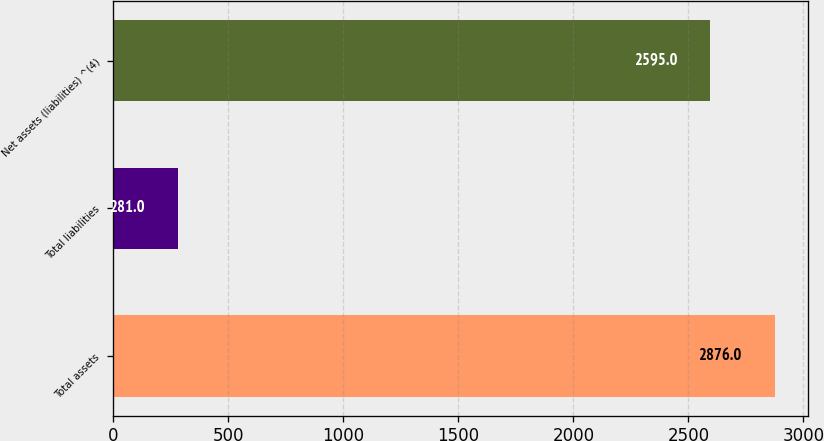Convert chart. <chart><loc_0><loc_0><loc_500><loc_500><bar_chart><fcel>Total assets<fcel>Total liabilities<fcel>Net assets (liabilities) ^(4)<nl><fcel>2876<fcel>281<fcel>2595<nl></chart> 